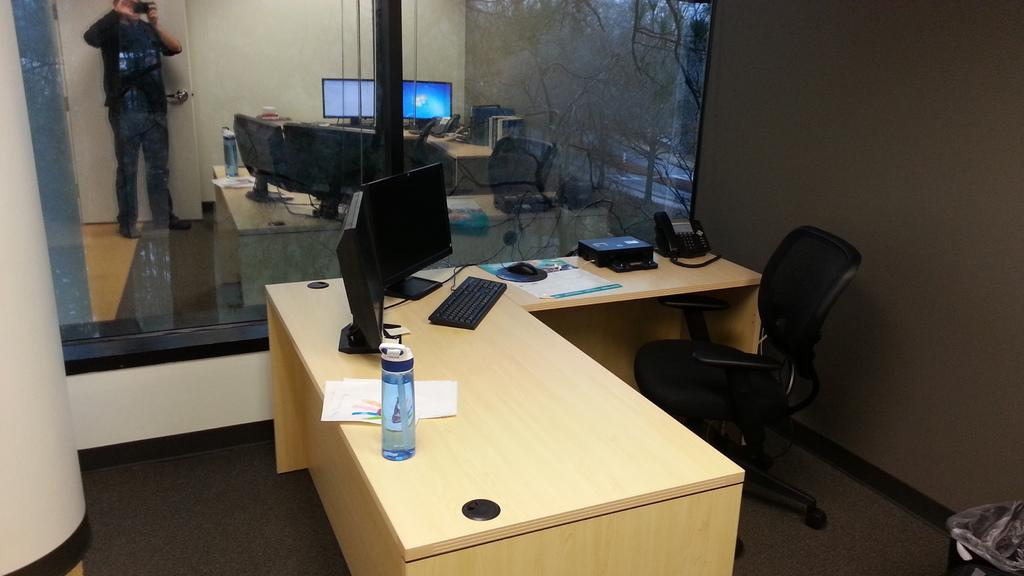What type of furniture is present in the image? There is a desk and a chair in the image. What is on top of the desk? There is a laptop, a bottle, and a telephone on the desk. What is the man in the image doing? The facts provided do not specify what the man is doing. Can you describe the electronic device on the desk? There is a laptop on the desk. Where is the scarecrow located in the image? There is no scarecrow present in the image. What type of hot beverage is in the bottle on the desk? The facts provided do not specify the contents of the bottle on the desk. 